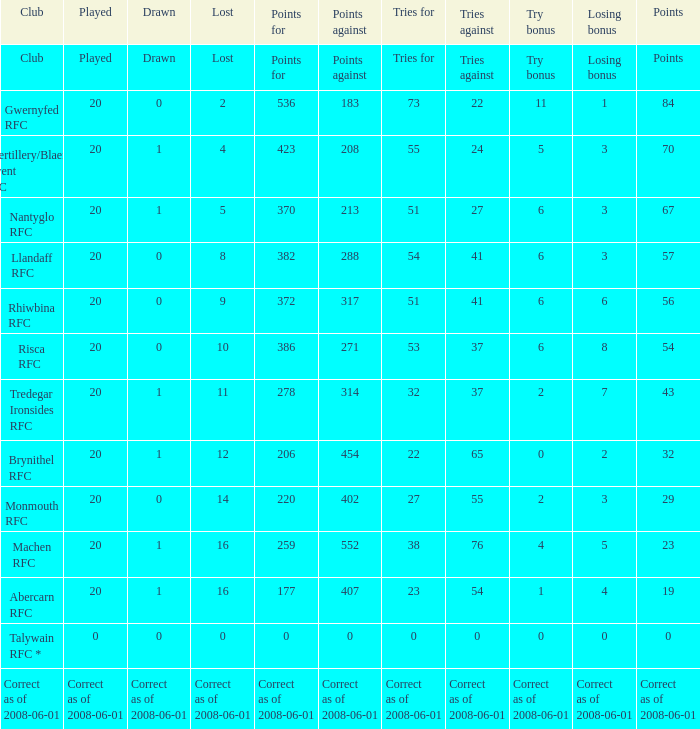If the points were 0, what were the tries for? 0.0. 